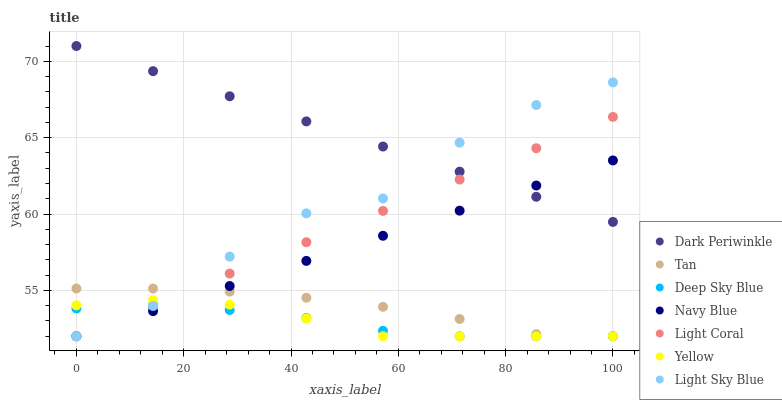Does Deep Sky Blue have the minimum area under the curve?
Answer yes or no. Yes. Does Dark Periwinkle have the maximum area under the curve?
Answer yes or no. Yes. Does Yellow have the minimum area under the curve?
Answer yes or no. No. Does Yellow have the maximum area under the curve?
Answer yes or no. No. Is Dark Periwinkle the smoothest?
Answer yes or no. Yes. Is Light Sky Blue the roughest?
Answer yes or no. Yes. Is Yellow the smoothest?
Answer yes or no. No. Is Yellow the roughest?
Answer yes or no. No. Does Navy Blue have the lowest value?
Answer yes or no. Yes. Does Dark Periwinkle have the lowest value?
Answer yes or no. No. Does Dark Periwinkle have the highest value?
Answer yes or no. Yes. Does Yellow have the highest value?
Answer yes or no. No. Is Tan less than Dark Periwinkle?
Answer yes or no. Yes. Is Dark Periwinkle greater than Deep Sky Blue?
Answer yes or no. Yes. Does Tan intersect Light Sky Blue?
Answer yes or no. Yes. Is Tan less than Light Sky Blue?
Answer yes or no. No. Is Tan greater than Light Sky Blue?
Answer yes or no. No. Does Tan intersect Dark Periwinkle?
Answer yes or no. No. 